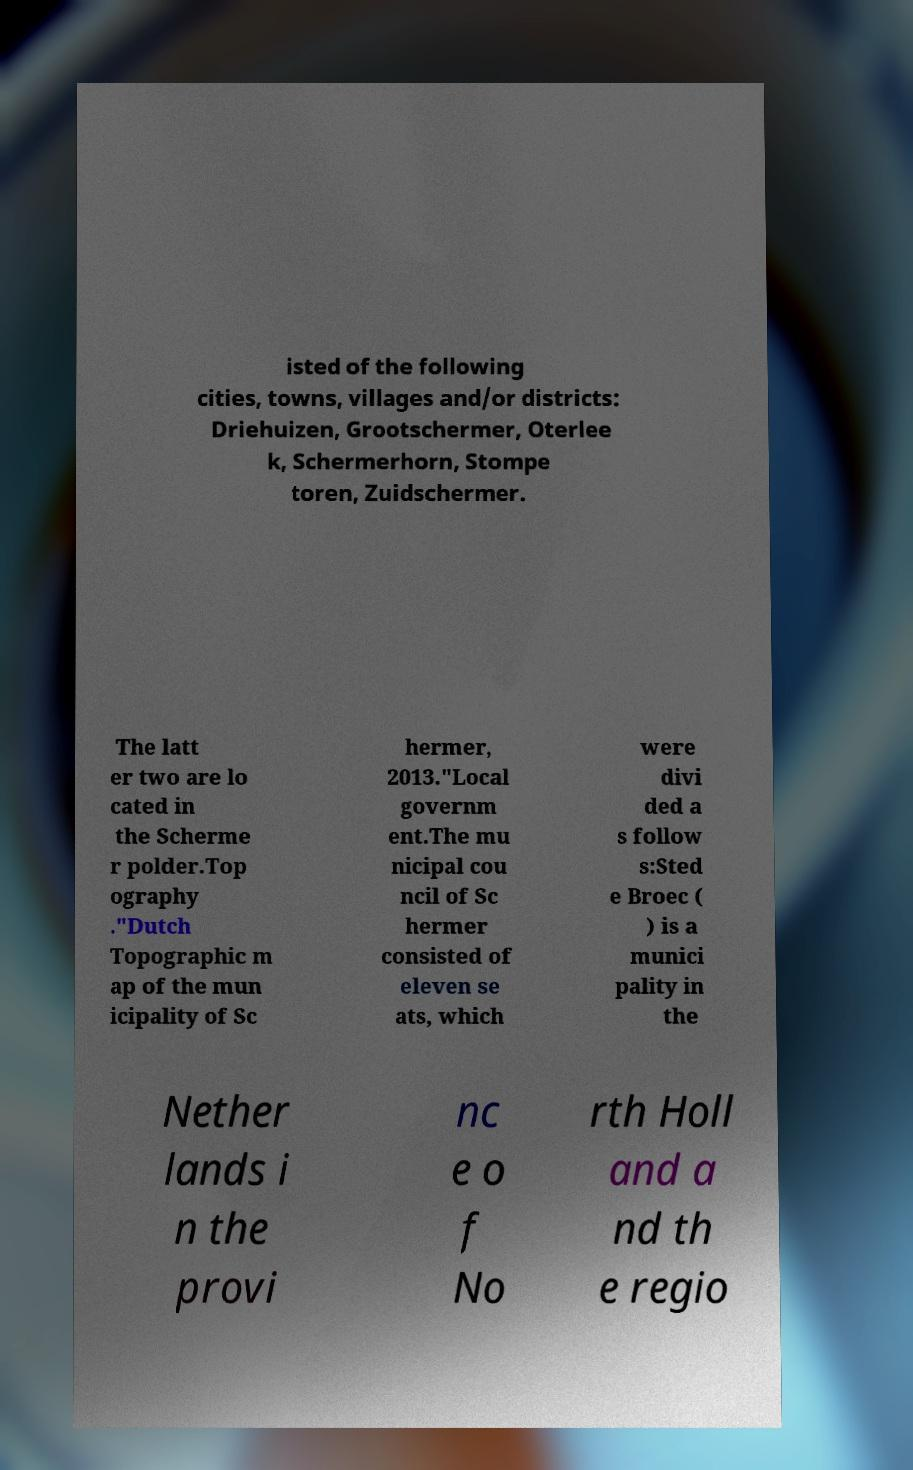Can you read and provide the text displayed in the image?This photo seems to have some interesting text. Can you extract and type it out for me? isted of the following cities, towns, villages and/or districts: Driehuizen, Grootschermer, Oterlee k, Schermerhorn, Stompe toren, Zuidschermer. The latt er two are lo cated in the Scherme r polder.Top ography ."Dutch Topographic m ap of the mun icipality of Sc hermer, 2013."Local governm ent.The mu nicipal cou ncil of Sc hermer consisted of eleven se ats, which were divi ded a s follow s:Sted e Broec ( ) is a munici pality in the Nether lands i n the provi nc e o f No rth Holl and a nd th e regio 